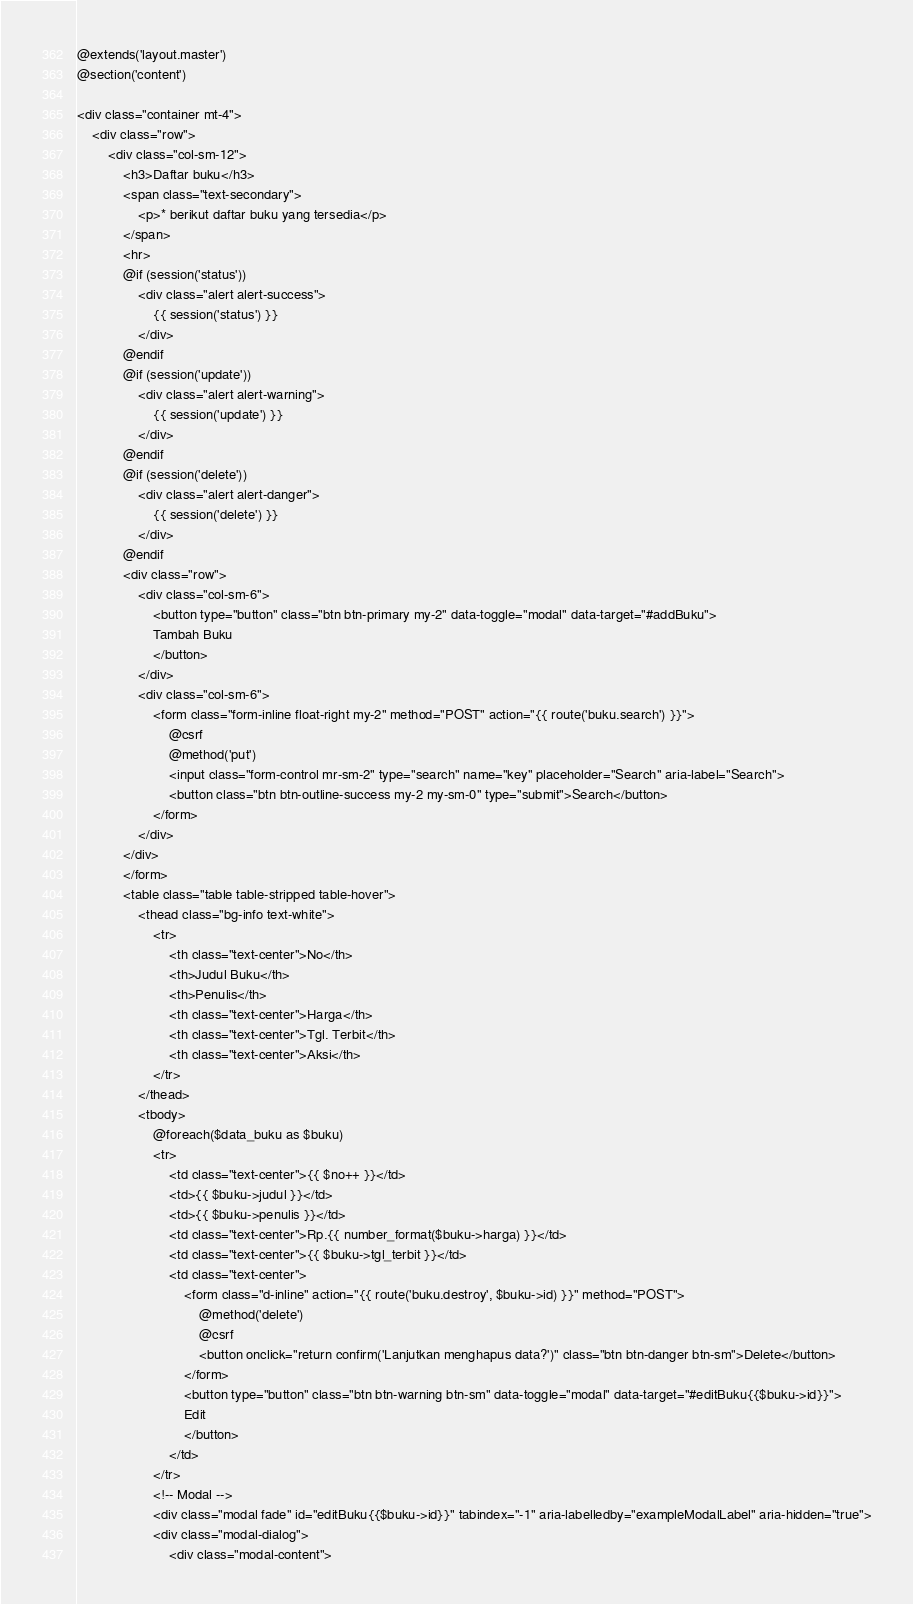Convert code to text. <code><loc_0><loc_0><loc_500><loc_500><_PHP_>@extends('layout.master')
@section('content')

<div class="container mt-4">
    <div class="row">
        <div class="col-sm-12">
            <h3>Daftar buku</h3>
            <span class="text-secondary">
                <p>* berikut daftar buku yang tersedia</p>
            </span>
            <hr>
            @if (session('status'))
                <div class="alert alert-success">
                    {{ session('status') }}
                </div>
            @endif
            @if (session('update'))
                <div class="alert alert-warning">
                    {{ session('update') }}
                </div>
            @endif
            @if (session('delete'))
                <div class="alert alert-danger">
                    {{ session('delete') }}
                </div>
            @endif
            <div class="row">
                <div class="col-sm-6">
                    <button type="button" class="btn btn-primary my-2" data-toggle="modal" data-target="#addBuku">
                    Tambah Buku
                    </button>
                </div>
                <div class="col-sm-6">
                    <form class="form-inline float-right my-2" method="POST" action="{{ route('buku.search') }}">
                        @csrf
                        @method('put')
                        <input class="form-control mr-sm-2" type="search" name="key" placeholder="Search" aria-label="Search">
                        <button class="btn btn-outline-success my-2 my-sm-0" type="submit">Search</button>
                    </form>
                </div>
            </div>
            </form>
            <table class="table table-stripped table-hover">
                <thead class="bg-info text-white">
                    <tr>
                        <th class="text-center">No</th>
                        <th>Judul Buku</th>
                        <th>Penulis</th>
                        <th class="text-center">Harga</th>
                        <th class="text-center">Tgl. Terbit</th>
                        <th class="text-center">Aksi</th>
                    </tr>
                </thead>
                <tbody>
                    @foreach($data_buku as $buku)
                    <tr>
                        <td class="text-center">{{ $no++ }}</td>
                        <td>{{ $buku->judul }}</td>
                        <td>{{ $buku->penulis }}</td>
                        <td class="text-center">Rp.{{ number_format($buku->harga) }}</td>
                        <td class="text-center">{{ $buku->tgl_terbit }}</td>
                        <td class="text-center">
                            <form class="d-inline" action="{{ route('buku.destroy', $buku->id) }}" method="POST">
                                @method('delete')
                                @csrf
                                <button onclick="return confirm('Lanjutkan menghapus data?')" class="btn btn-danger btn-sm">Delete</button>
                            </form>
                            <button type="button" class="btn btn-warning btn-sm" data-toggle="modal" data-target="#editBuku{{$buku->id}}">
                            Edit
                            </button>
                        </td>
                    </tr>
                    <!-- Modal -->
                    <div class="modal fade" id="editBuku{{$buku->id}}" tabindex="-1" aria-labelledby="exampleModalLabel" aria-hidden="true">
                    <div class="modal-dialog">
                        <div class="modal-content"></code> 